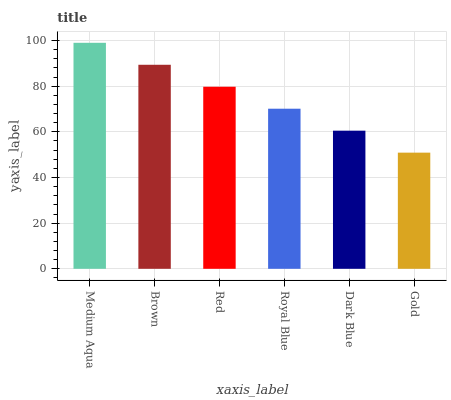Is Gold the minimum?
Answer yes or no. Yes. Is Medium Aqua the maximum?
Answer yes or no. Yes. Is Brown the minimum?
Answer yes or no. No. Is Brown the maximum?
Answer yes or no. No. Is Medium Aqua greater than Brown?
Answer yes or no. Yes. Is Brown less than Medium Aqua?
Answer yes or no. Yes. Is Brown greater than Medium Aqua?
Answer yes or no. No. Is Medium Aqua less than Brown?
Answer yes or no. No. Is Red the high median?
Answer yes or no. Yes. Is Royal Blue the low median?
Answer yes or no. Yes. Is Gold the high median?
Answer yes or no. No. Is Medium Aqua the low median?
Answer yes or no. No. 